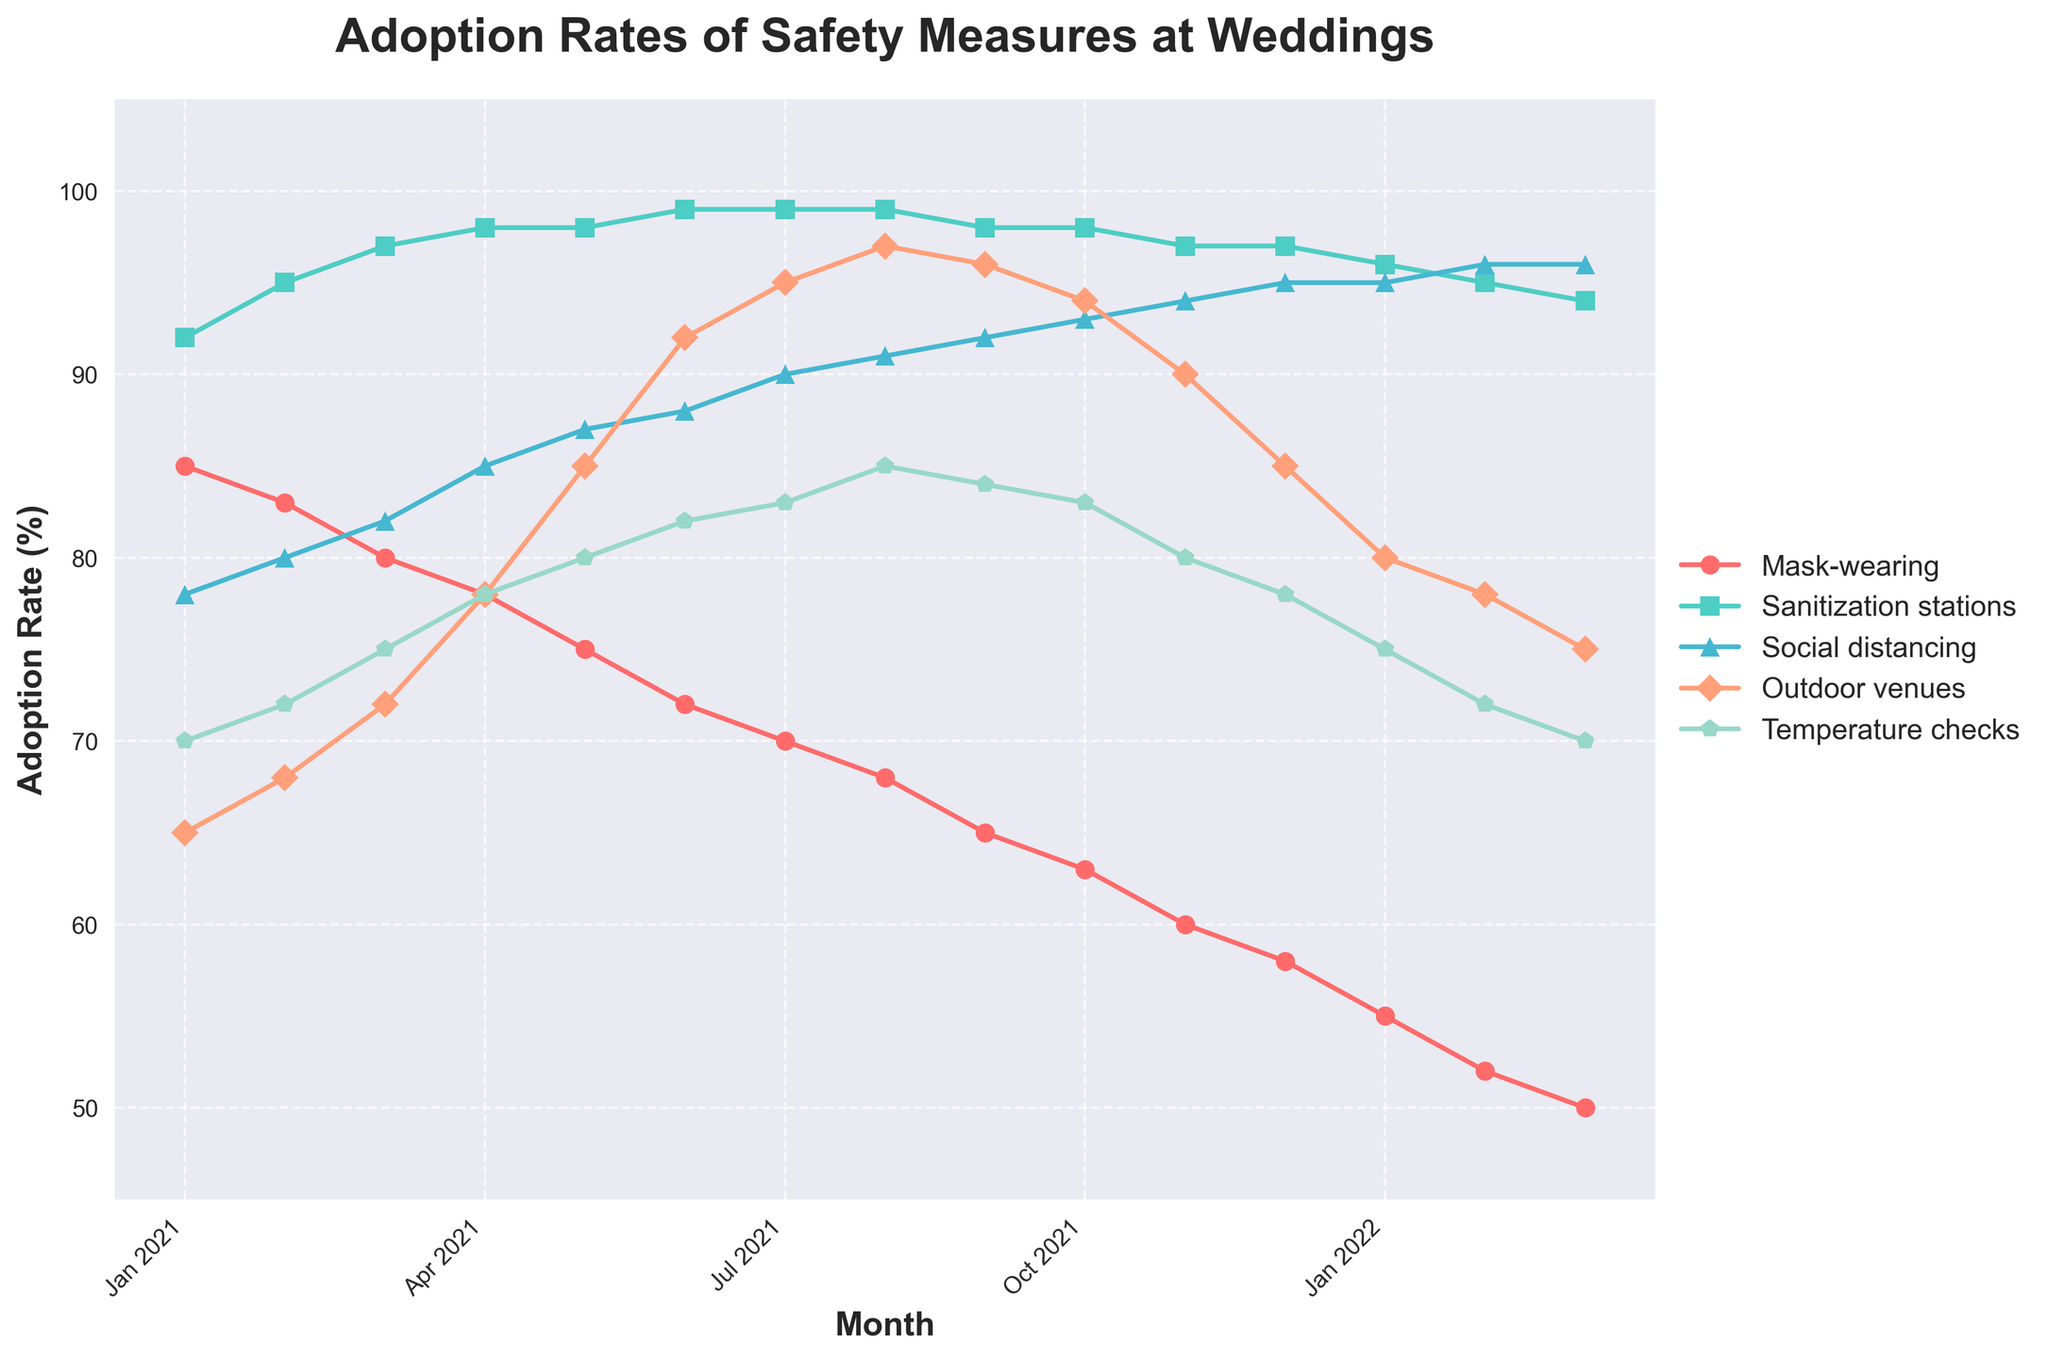What safety measure had the highest adoption rate in January 2021? Looking at January 2021 in the chart, the data point for "Sanitization stations" is the highest at around 92%.
Answer: Sanitization stations What is the trend in the adoption rate of mask-wearing from January 2021 to March 2022? Observing the line for "Mask-wearing", it shows a steady decline from 85% in January 2021 to 50% in March 2022.
Answer: Declining In which month did outdoor venues reach their peak adoption rate, and what was it? The line for "Outdoor venues" peaks in August 2021, reaching the highest point at around 97%.
Answer: August 2021, 97% How does the adoption rate of social distancing in June 2021 compare to that in March 2022? In June 2021, social distancing has a rate of 88%, whereas in March 2022, it is 96%. Hence, it increased from June 2021 to March 2022.
Answer: Increased What's the average adoption rate of temperature checks in the second half of 2021? For the months of July to December 2021, the values are 83, 85, 84, 83, 80, and 78. Summing these gives 493, and averaging gives 493/6 = ~82.17%.
Answer: ~82.17% Which safety measure showed the least fluctuation in adoption rates over the period? Observing the lines, "Sanitization stations" shows the least fluctuation, staying consistently around 95-99% throughout.
Answer: Sanitization stations Between January 2021 and January 2022, which safety measure saw the steepest decline in adoption rates? Comparing adoption rates from January 2021 to January 2022, "Mask-wearing" dropped from 85% to 55%, a decrease of 30%, which is the steepest.
Answer: Mask-wearing How does the trend for outdoor venues compare to temperature checks over 2021? Both "Outdoor venues" and "Temperature checks" show an upward trend during the first eight months, but "Outdoor venues" peak in August while "Temperature checks" peak earlier and then decline.
Answer: Upward then downward for both, but peaks differ If you sum up the adoption rates of "Mask-wearing" and "Sanitization stations" for March 2021, what do you get? The adoption rates are 80% and 97% respectively. Summing these, we get 80 + 97 = 177%.
Answer: 177% 